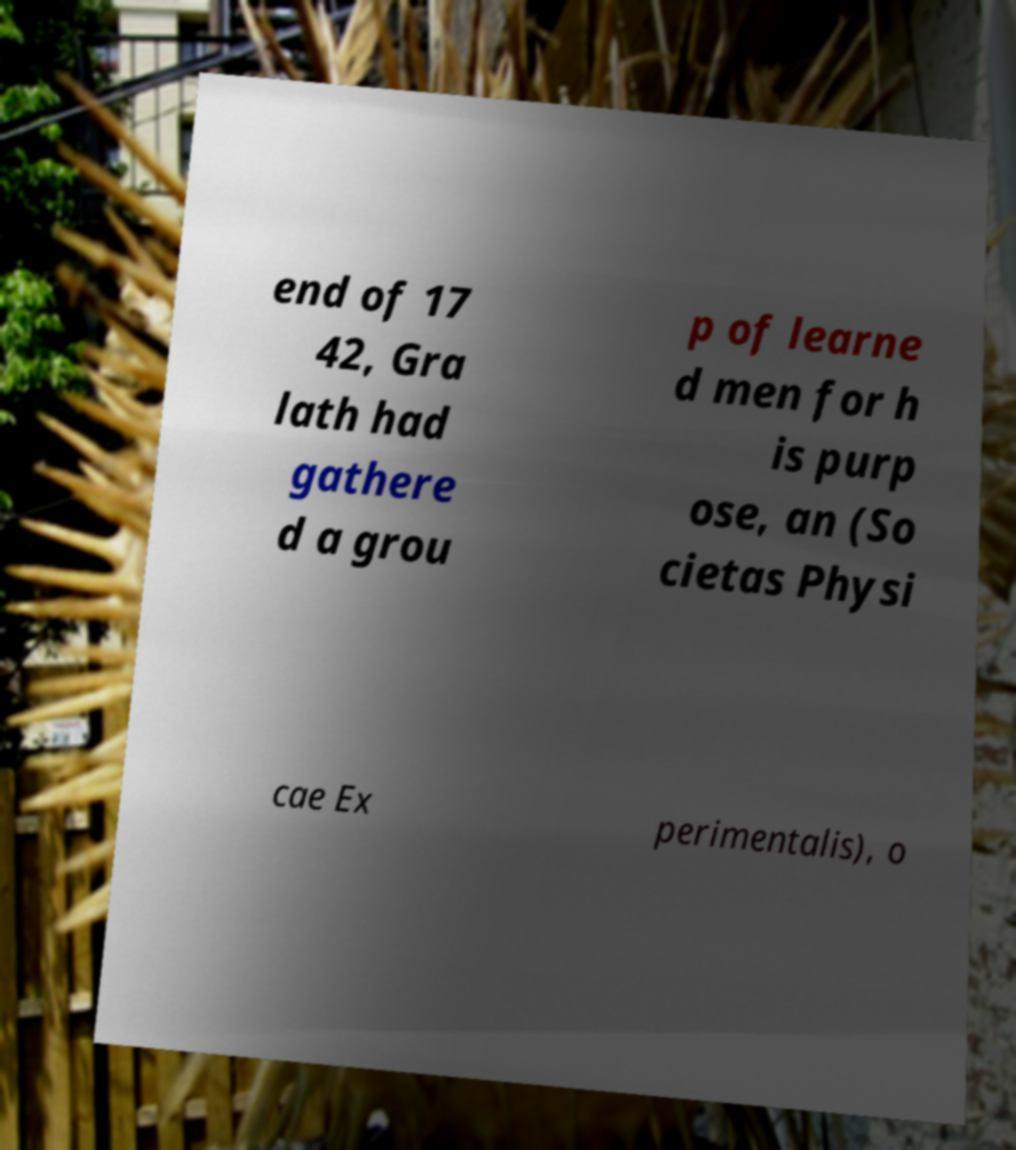Could you extract and type out the text from this image? end of 17 42, Gra lath had gathere d a grou p of learne d men for h is purp ose, an (So cietas Physi cae Ex perimentalis), o 